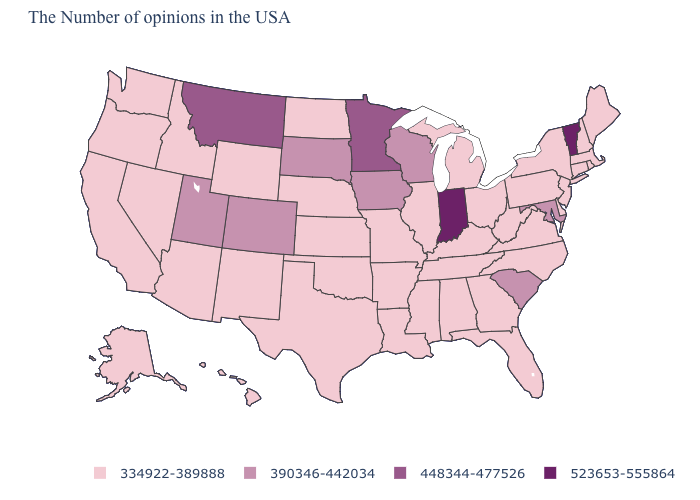Which states have the highest value in the USA?
Concise answer only. Vermont, Indiana. Which states have the highest value in the USA?
Be succinct. Vermont, Indiana. What is the value of Maine?
Concise answer only. 334922-389888. What is the value of Illinois?
Keep it brief. 334922-389888. What is the value of New Hampshire?
Be succinct. 334922-389888. Name the states that have a value in the range 390346-442034?
Write a very short answer. Maryland, South Carolina, Wisconsin, Iowa, South Dakota, Colorado, Utah. Which states have the highest value in the USA?
Short answer required. Vermont, Indiana. Name the states that have a value in the range 334922-389888?
Short answer required. Maine, Massachusetts, Rhode Island, New Hampshire, Connecticut, New York, New Jersey, Delaware, Pennsylvania, Virginia, North Carolina, West Virginia, Ohio, Florida, Georgia, Michigan, Kentucky, Alabama, Tennessee, Illinois, Mississippi, Louisiana, Missouri, Arkansas, Kansas, Nebraska, Oklahoma, Texas, North Dakota, Wyoming, New Mexico, Arizona, Idaho, Nevada, California, Washington, Oregon, Alaska, Hawaii. What is the highest value in states that border Minnesota?
Be succinct. 390346-442034. Is the legend a continuous bar?
Answer briefly. No. What is the value of New Jersey?
Give a very brief answer. 334922-389888. Which states have the lowest value in the MidWest?
Write a very short answer. Ohio, Michigan, Illinois, Missouri, Kansas, Nebraska, North Dakota. Does New Jersey have the same value as South Carolina?
Write a very short answer. No. What is the value of New Jersey?
Answer briefly. 334922-389888. Which states have the lowest value in the USA?
Quick response, please. Maine, Massachusetts, Rhode Island, New Hampshire, Connecticut, New York, New Jersey, Delaware, Pennsylvania, Virginia, North Carolina, West Virginia, Ohio, Florida, Georgia, Michigan, Kentucky, Alabama, Tennessee, Illinois, Mississippi, Louisiana, Missouri, Arkansas, Kansas, Nebraska, Oklahoma, Texas, North Dakota, Wyoming, New Mexico, Arizona, Idaho, Nevada, California, Washington, Oregon, Alaska, Hawaii. 